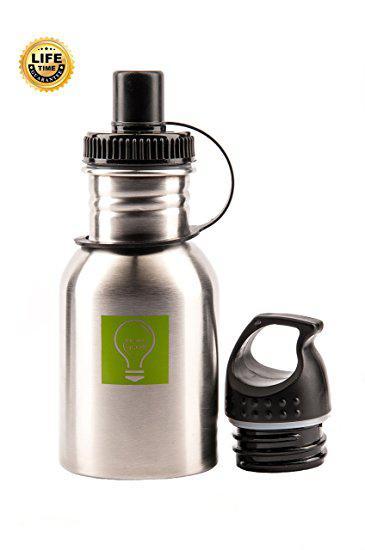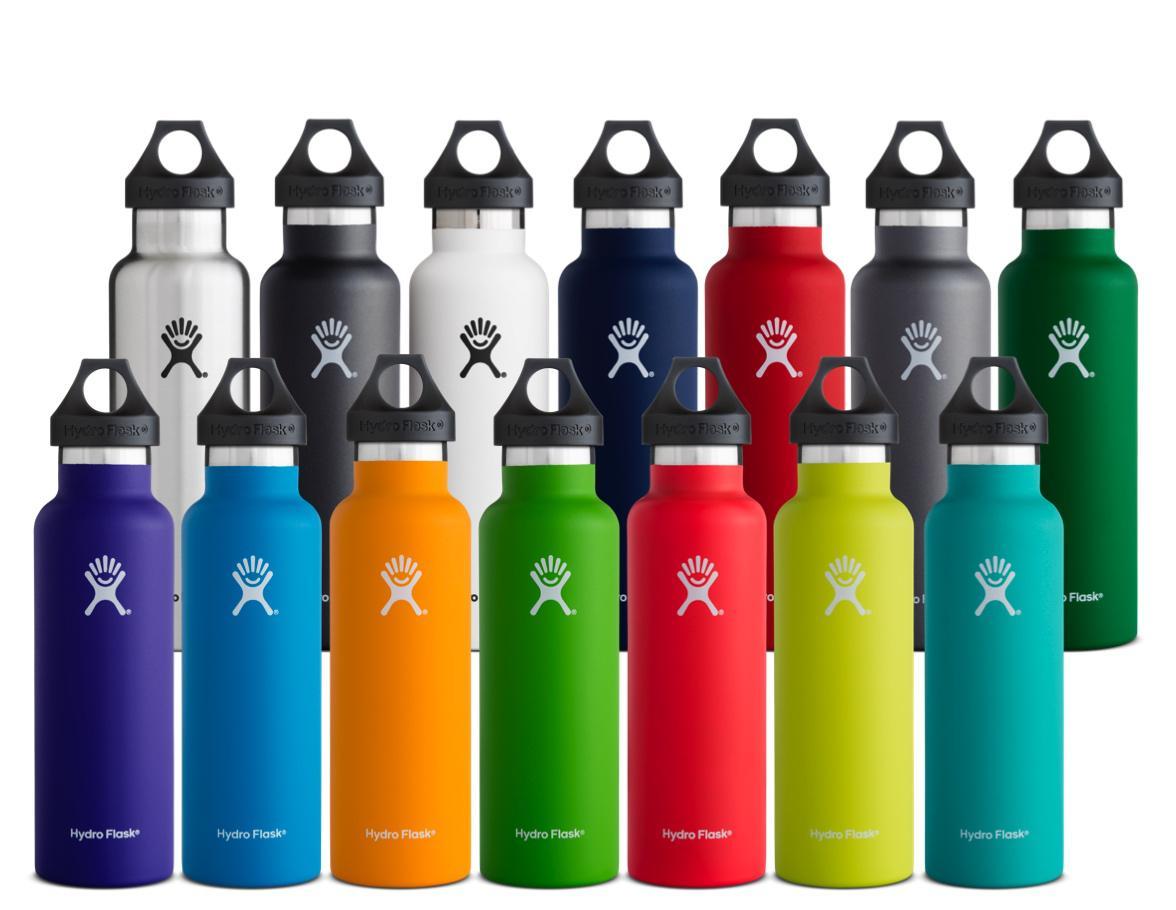The first image is the image on the left, the second image is the image on the right. Examine the images to the left and right. Is the description "The left and right image contains the same number of rows of stainless steel water bottles." accurate? Answer yes or no. No. The first image is the image on the left, the second image is the image on the right. Examine the images to the left and right. Is the description "There are fifteen bottles in total." accurate? Answer yes or no. Yes. 